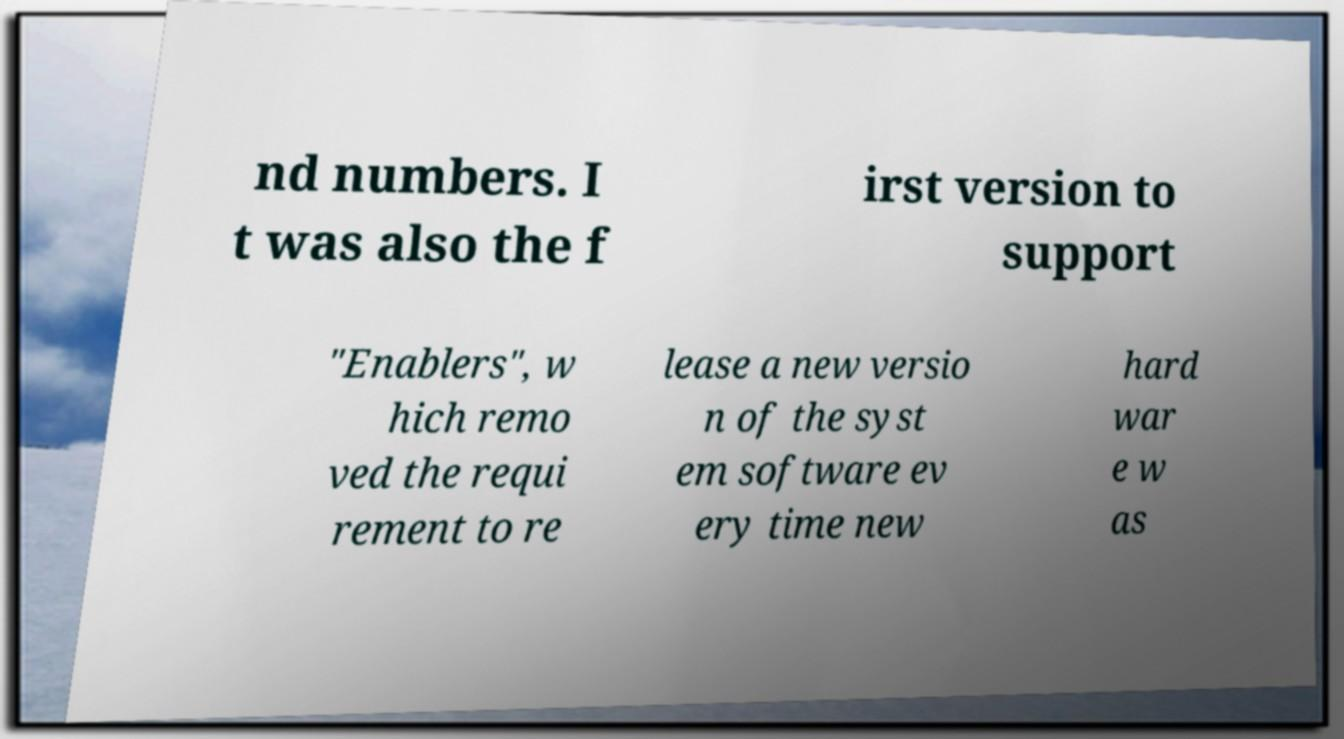For documentation purposes, I need the text within this image transcribed. Could you provide that? nd numbers. I t was also the f irst version to support "Enablers", w hich remo ved the requi rement to re lease a new versio n of the syst em software ev ery time new hard war e w as 